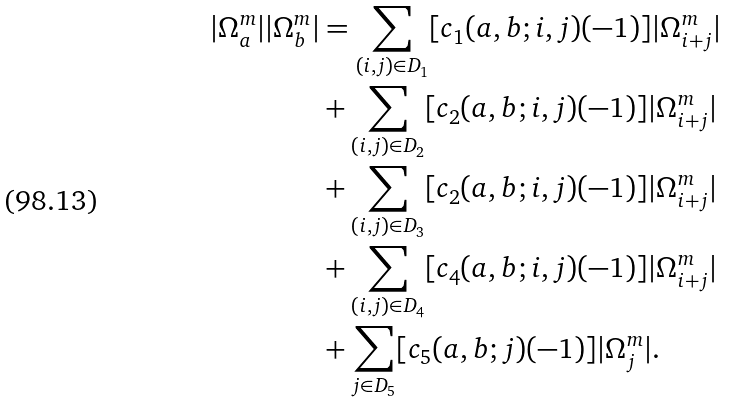Convert formula to latex. <formula><loc_0><loc_0><loc_500><loc_500>| \Omega _ { a } ^ { m } | | \Omega _ { b } ^ { m } | & = \sum _ { ( i , j ) \in D _ { 1 } } [ c _ { 1 } ( a , b ; i , j ) ( - 1 ) ] | \Omega _ { i + j } ^ { m } | \\ & + \sum _ { ( i , j ) \in D _ { 2 } } [ c _ { 2 } ( a , b ; i , j ) ( - 1 ) ] | \Omega _ { i + j } ^ { m } | \\ & + \sum _ { ( i , j ) \in D _ { 3 } } [ c _ { 2 } ( a , b ; i , j ) ( - 1 ) ] | \Omega _ { i + j } ^ { m } | \\ & + \sum _ { ( i , j ) \in D _ { 4 } } [ c _ { 4 } ( a , b ; i , j ) ( - 1 ) ] | \Omega _ { i + j } ^ { m } | \\ & + \sum _ { j \in D _ { 5 } } [ c _ { 5 } ( a , b ; j ) ( - 1 ) ] | \Omega _ { j } ^ { m } | .</formula> 